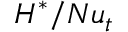Convert formula to latex. <formula><loc_0><loc_0><loc_500><loc_500>H ^ { * } / N u _ { t }</formula> 